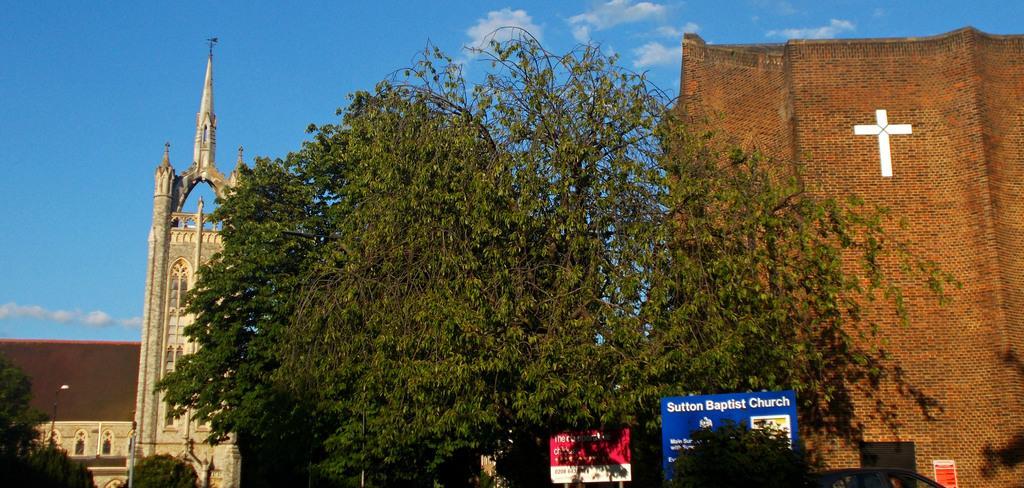In one or two sentences, can you explain what this image depicts? In this picture we can see name boards, vehicle, trees, buildings and in the background we can see sky with clouds. 